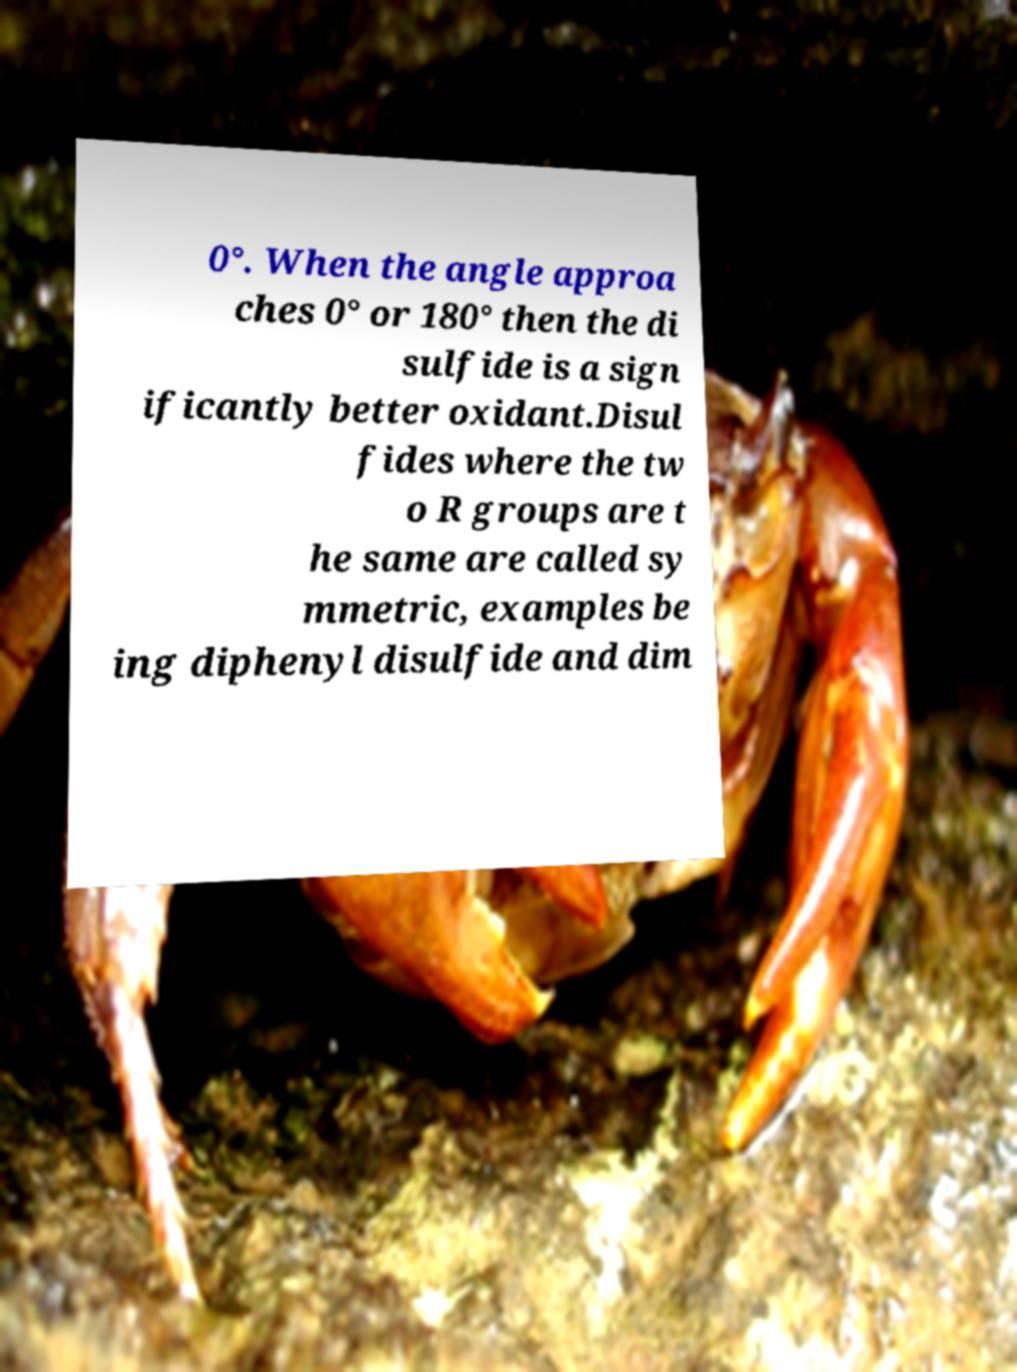For documentation purposes, I need the text within this image transcribed. Could you provide that? 0°. When the angle approa ches 0° or 180° then the di sulfide is a sign ificantly better oxidant.Disul fides where the tw o R groups are t he same are called sy mmetric, examples be ing diphenyl disulfide and dim 